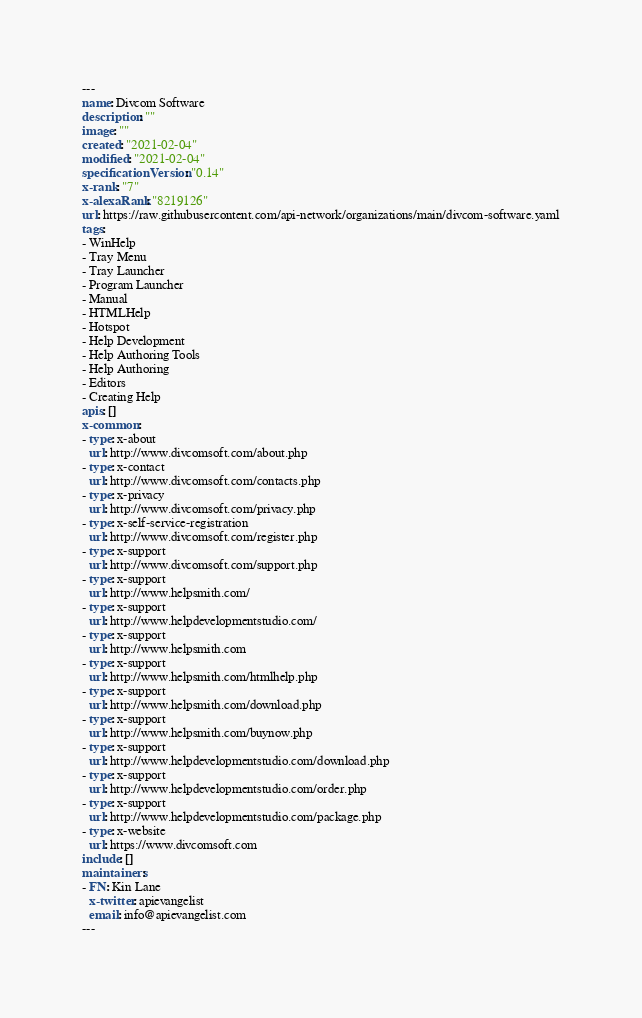Convert code to text. <code><loc_0><loc_0><loc_500><loc_500><_YAML_>---
name: Divcom Software
description: ""
image: ""
created: "2021-02-04"
modified: "2021-02-04"
specificationVersion: "0.14"
x-rank: "7"
x-alexaRank: "8219126"
url: https://raw.githubusercontent.com/api-network/organizations/main/divcom-software.yaml
tags:
- WinHelp
- Tray Menu
- Tray Launcher
- Program Launcher
- Manual
- HTMLHelp
- Hotspot
- Help Development
- Help Authoring Tools
- Help Authoring
- Editors
- Creating Help
apis: []
x-common:
- type: x-about
  url: http://www.divcomsoft.com/about.php
- type: x-contact
  url: http://www.divcomsoft.com/contacts.php
- type: x-privacy
  url: http://www.divcomsoft.com/privacy.php
- type: x-self-service-registration
  url: http://www.divcomsoft.com/register.php
- type: x-support
  url: http://www.divcomsoft.com/support.php
- type: x-support
  url: http://www.helpsmith.com/
- type: x-support
  url: http://www.helpdevelopmentstudio.com/
- type: x-support
  url: http://www.helpsmith.com
- type: x-support
  url: http://www.helpsmith.com/htmlhelp.php
- type: x-support
  url: http://www.helpsmith.com/download.php
- type: x-support
  url: http://www.helpsmith.com/buynow.php
- type: x-support
  url: http://www.helpdevelopmentstudio.com/download.php
- type: x-support
  url: http://www.helpdevelopmentstudio.com/order.php
- type: x-support
  url: http://www.helpdevelopmentstudio.com/package.php
- type: x-website
  url: https://www.divcomsoft.com
include: []
maintainers:
- FN: Kin Lane
  x-twitter: apievangelist
  email: info@apievangelist.com
---</code> 